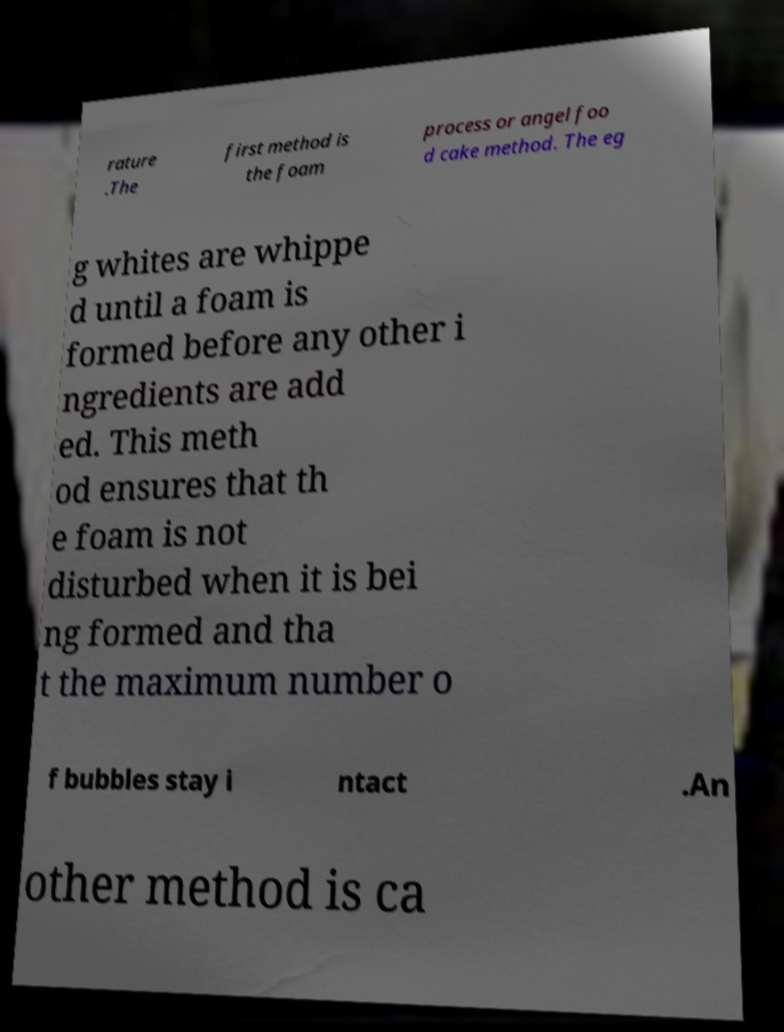I need the written content from this picture converted into text. Can you do that? rature .The first method is the foam process or angel foo d cake method. The eg g whites are whippe d until a foam is formed before any other i ngredients are add ed. This meth od ensures that th e foam is not disturbed when it is bei ng formed and tha t the maximum number o f bubbles stay i ntact .An other method is ca 